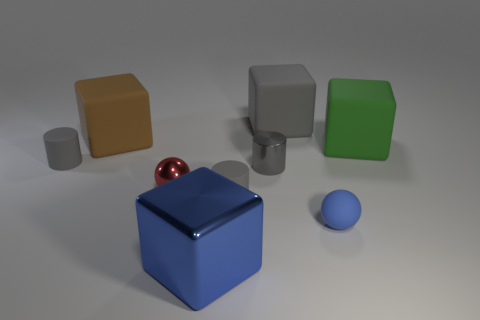Subtract all green rubber blocks. How many blocks are left? 3 Add 1 large gray rubber cubes. How many objects exist? 10 Subtract all red balls. How many balls are left? 1 Subtract all balls. How many objects are left? 7 Subtract all red cubes. Subtract all purple balls. How many cubes are left? 4 Subtract all small red things. Subtract all blocks. How many objects are left? 4 Add 5 red metallic things. How many red metallic things are left? 6 Add 1 green matte things. How many green matte things exist? 2 Subtract 0 gray balls. How many objects are left? 9 Subtract 1 cylinders. How many cylinders are left? 2 